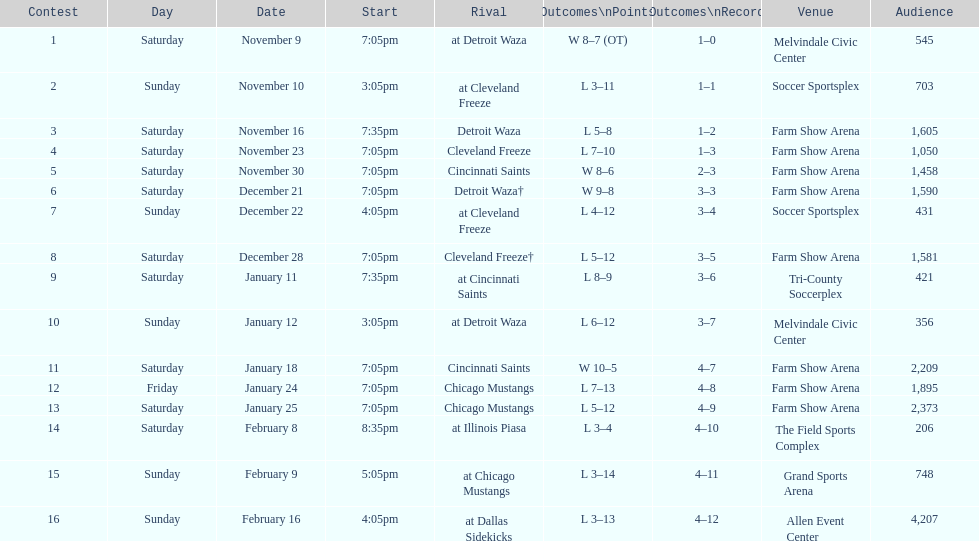How many games did the harrisburg heat lose to the cleveland freeze in total. 4. 